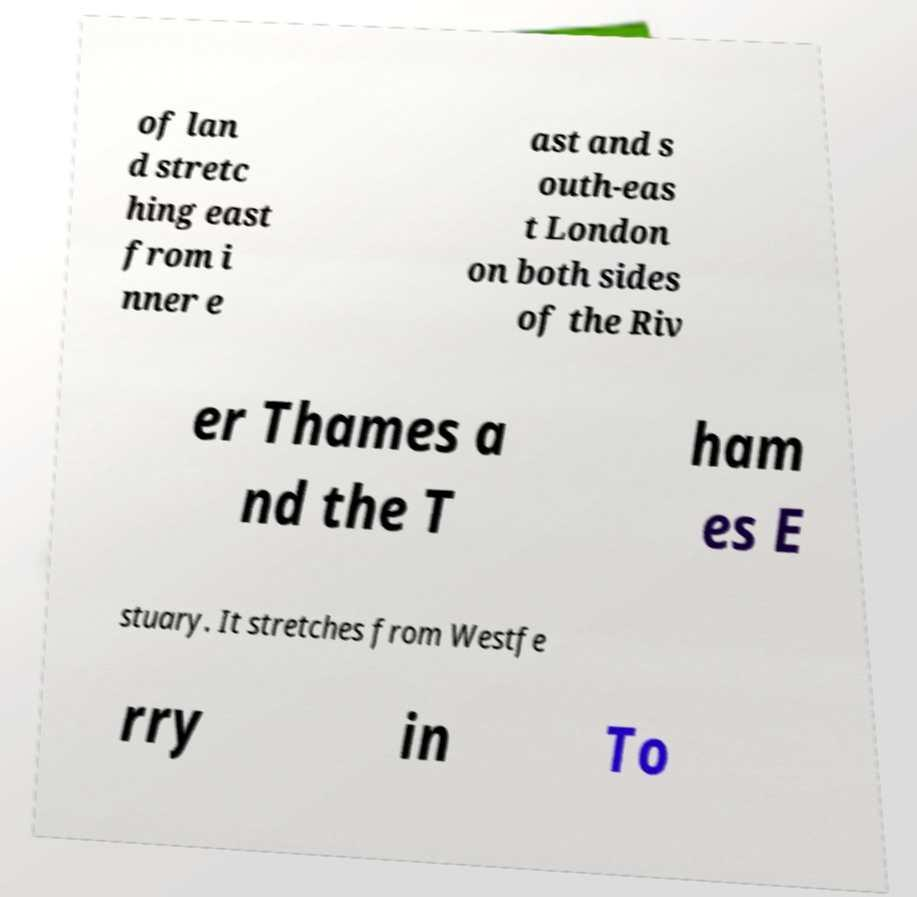There's text embedded in this image that I need extracted. Can you transcribe it verbatim? of lan d stretc hing east from i nner e ast and s outh-eas t London on both sides of the Riv er Thames a nd the T ham es E stuary. It stretches from Westfe rry in To 